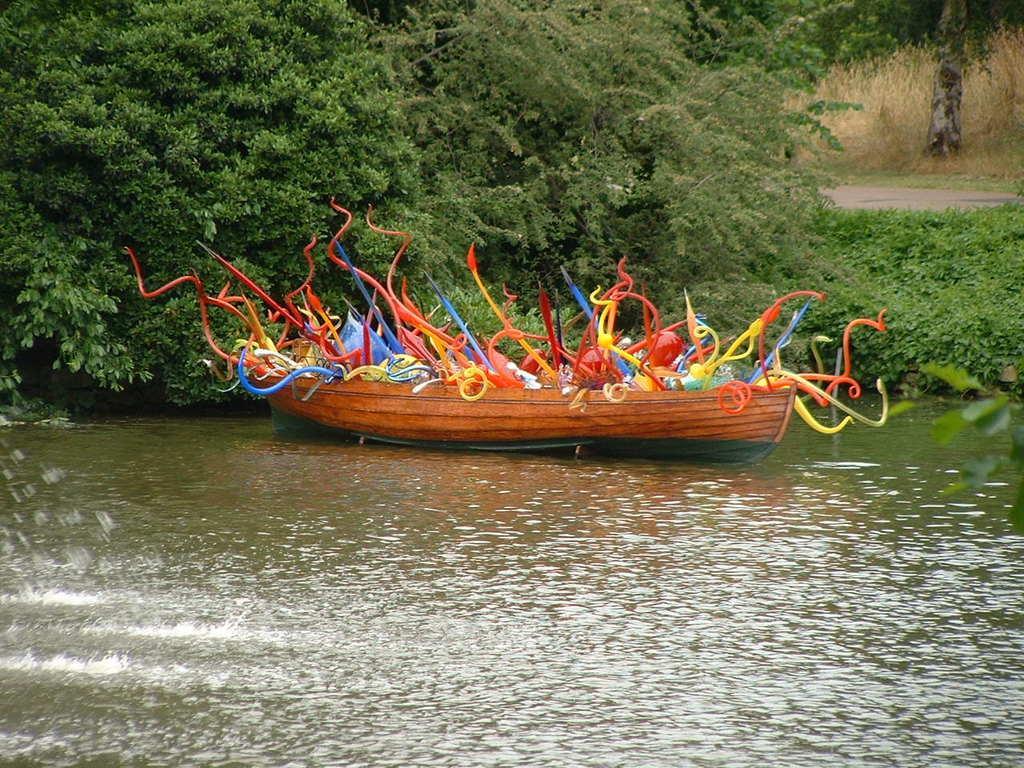Could you give a brief overview of what you see in this image? In this image, we can see a boat floating on the water. There is are some trees and plants in the middle of the image. There is a stem in the top right of the image. 